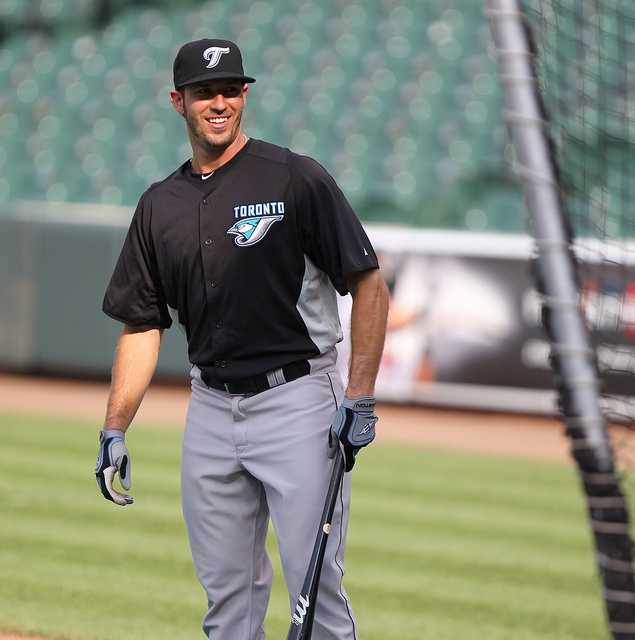Describe the objects in this image and their specific colors. I can see people in gray, black, darkgray, and tan tones and baseball bat in gray and black tones in this image. 